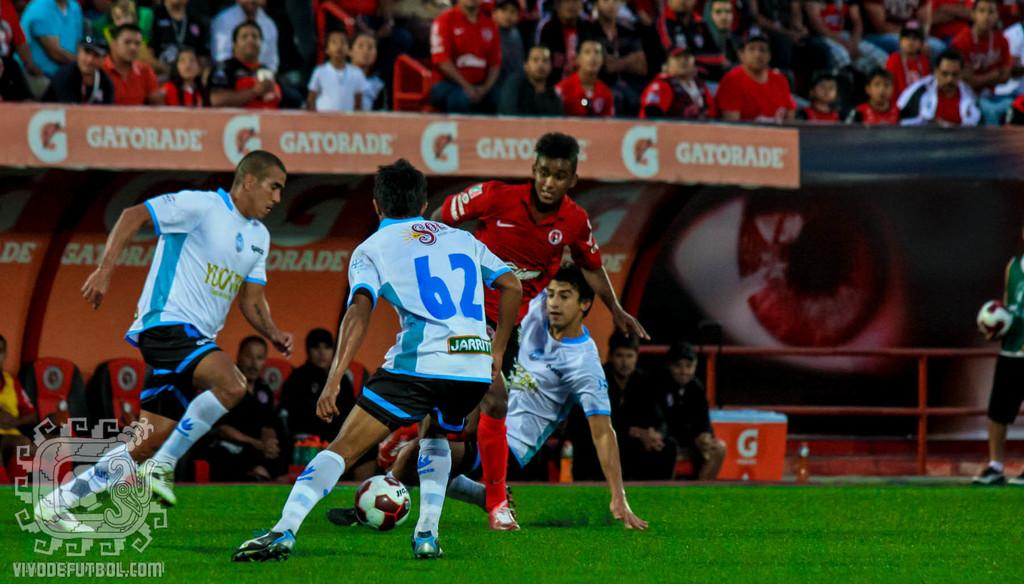<image>
Summarize the visual content of the image. #62 battles with other players for the ball in a soccer game in a Gatorade sponsored stadium. 